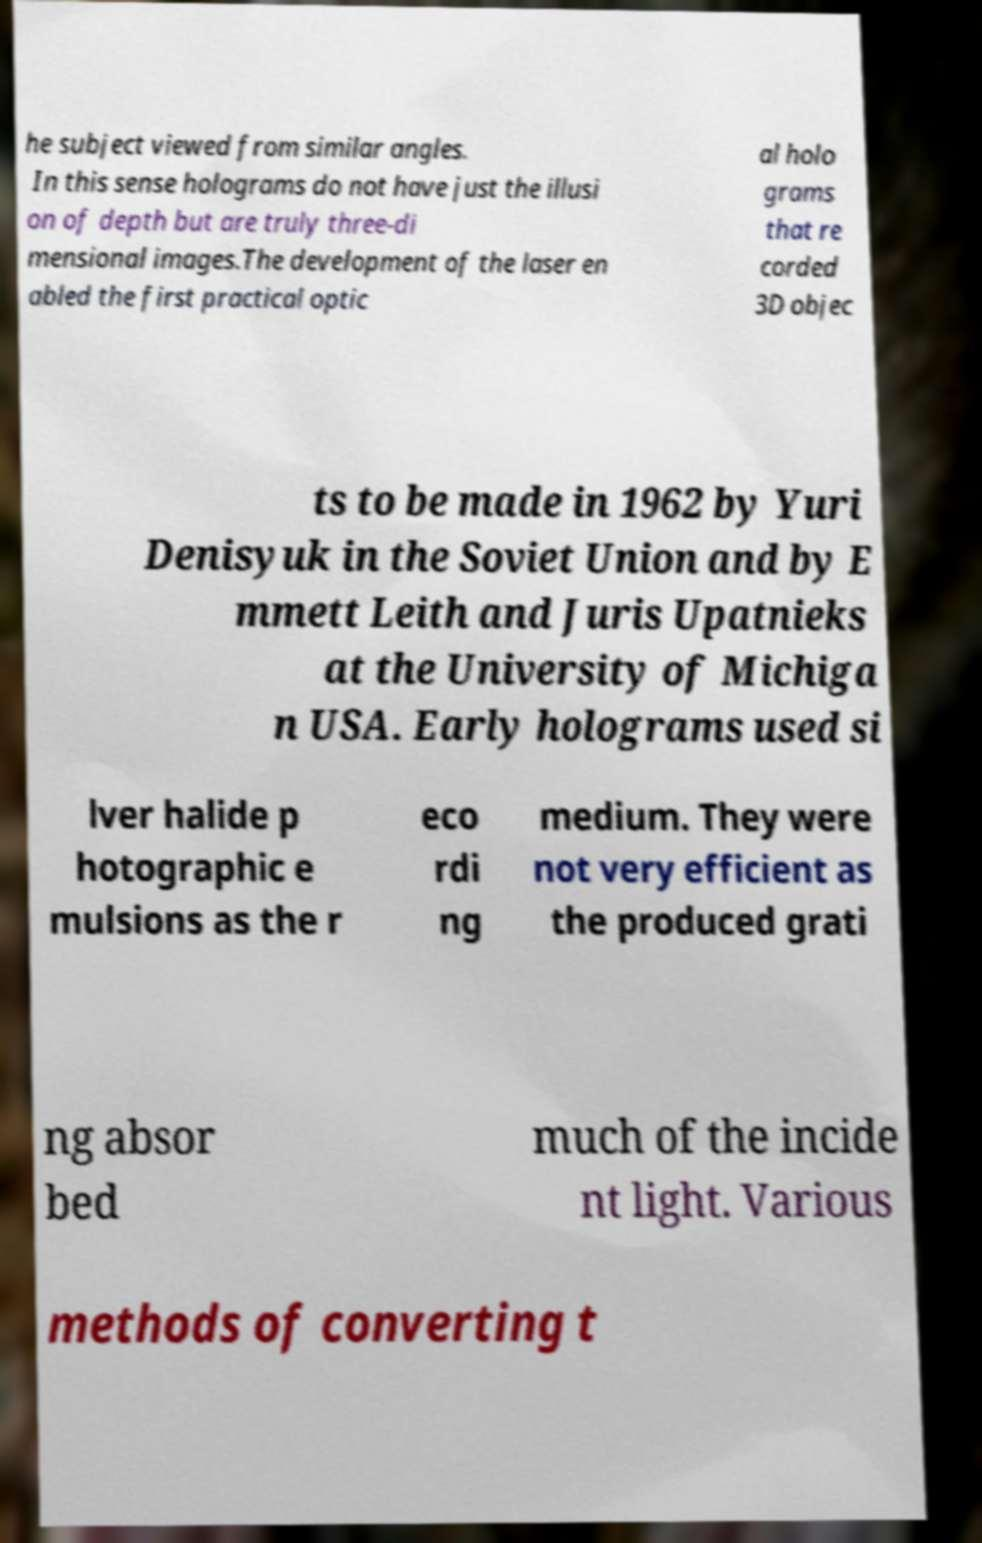For documentation purposes, I need the text within this image transcribed. Could you provide that? he subject viewed from similar angles. In this sense holograms do not have just the illusi on of depth but are truly three-di mensional images.The development of the laser en abled the first practical optic al holo grams that re corded 3D objec ts to be made in 1962 by Yuri Denisyuk in the Soviet Union and by E mmett Leith and Juris Upatnieks at the University of Michiga n USA. Early holograms used si lver halide p hotographic e mulsions as the r eco rdi ng medium. They were not very efficient as the produced grati ng absor bed much of the incide nt light. Various methods of converting t 